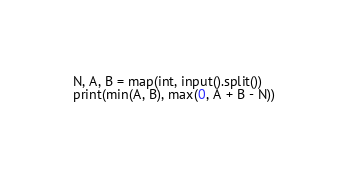<code> <loc_0><loc_0><loc_500><loc_500><_Python_>N, A, B = map(int, input().split())
print(min(A, B), max(0, A + B - N))</code> 